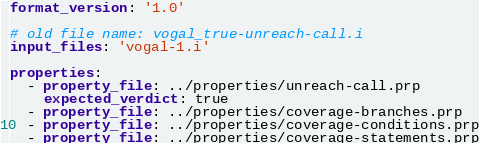Convert code to text. <code><loc_0><loc_0><loc_500><loc_500><_YAML_>format_version: '1.0'

# old file name: vogal_true-unreach-call.i
input_files: 'vogal-1.i'

properties:
  - property_file: ../properties/unreach-call.prp
    expected_verdict: true
  - property_file: ../properties/coverage-branches.prp
  - property_file: ../properties/coverage-conditions.prp
  - property_file: ../properties/coverage-statements.prp
</code> 